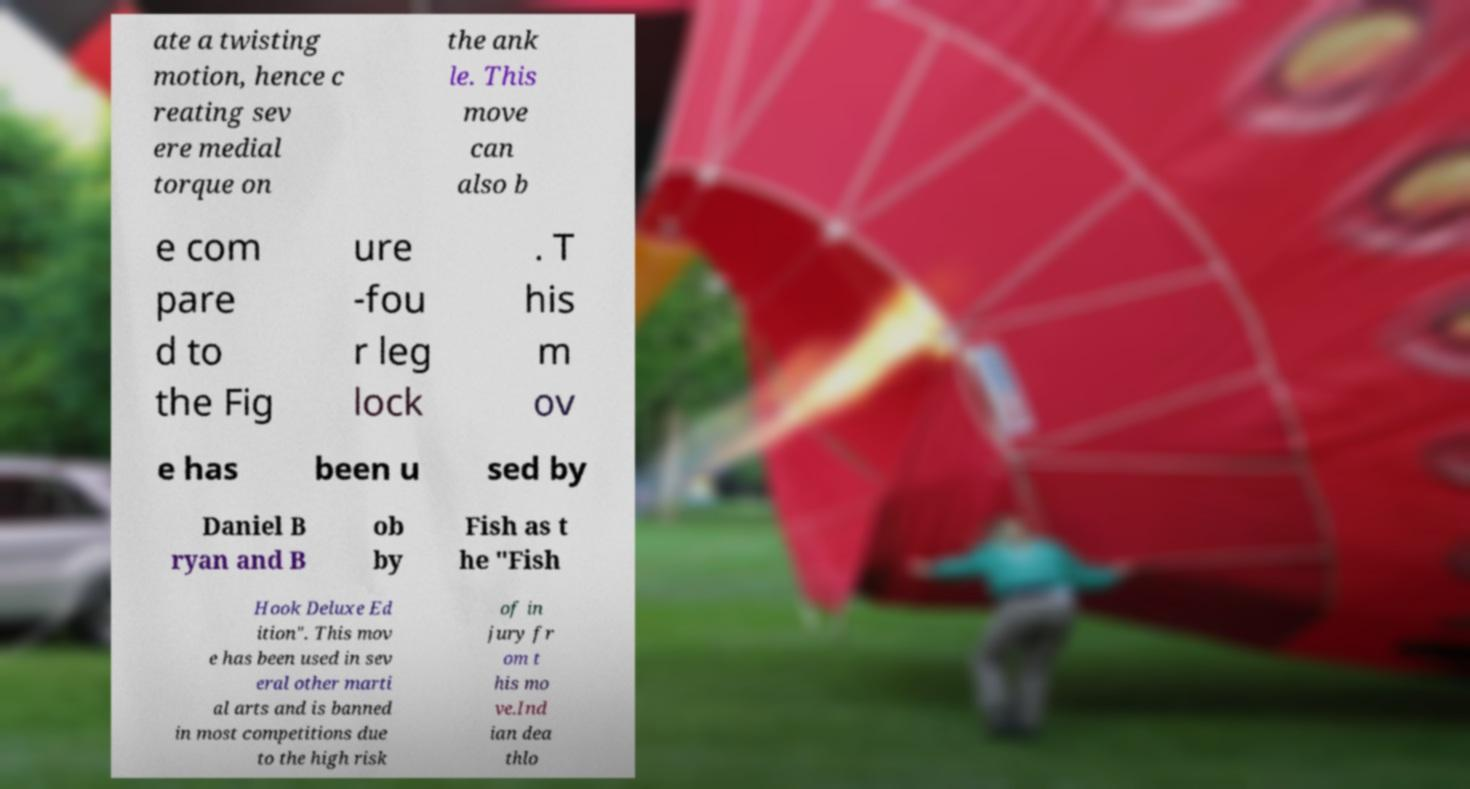What messages or text are displayed in this image? I need them in a readable, typed format. ate a twisting motion, hence c reating sev ere medial torque on the ank le. This move can also b e com pare d to the Fig ure -fou r leg lock . T his m ov e has been u sed by Daniel B ryan and B ob by Fish as t he "Fish Hook Deluxe Ed ition". This mov e has been used in sev eral other marti al arts and is banned in most competitions due to the high risk of in jury fr om t his mo ve.Ind ian dea thlo 